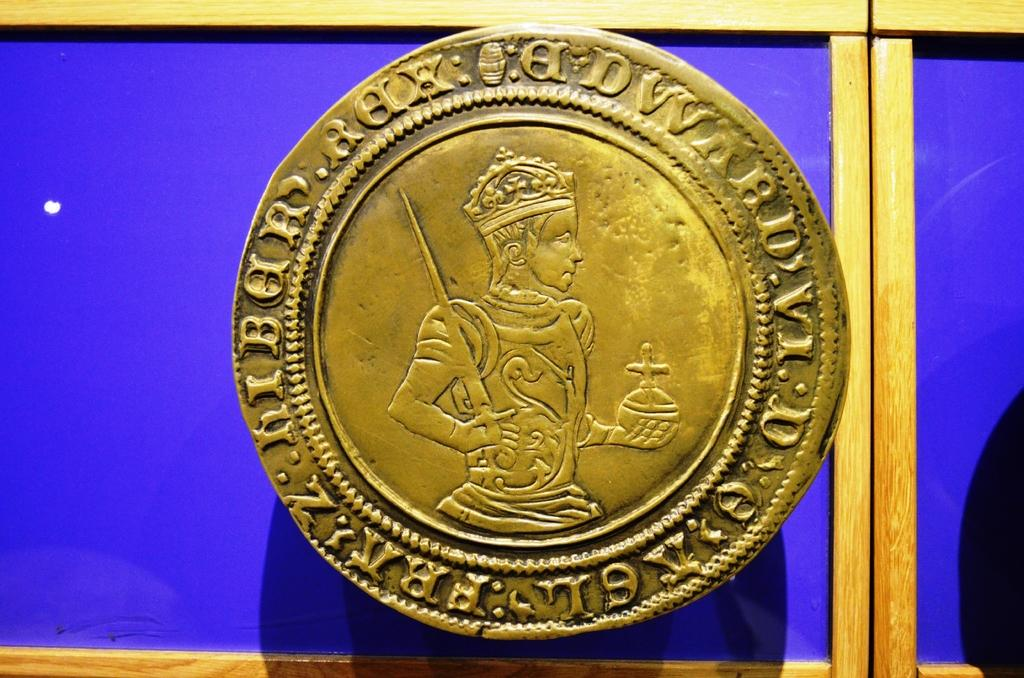What object is the main focus of the picture? The main object in the picture is a coin. What can be seen on the surface of the coin? The coin has letters on it. Is there any symbol or figure on the coin? Yes, there is a structure resembling a person on the coin. What is visible in the background of the picture? There is a board in the background of the picture. Is there a fireman putting out a current on the coin? No, there is no fireman or current present on the coin. The coin features a person-like structure, but it does not resemble a fireman or depict any current. 